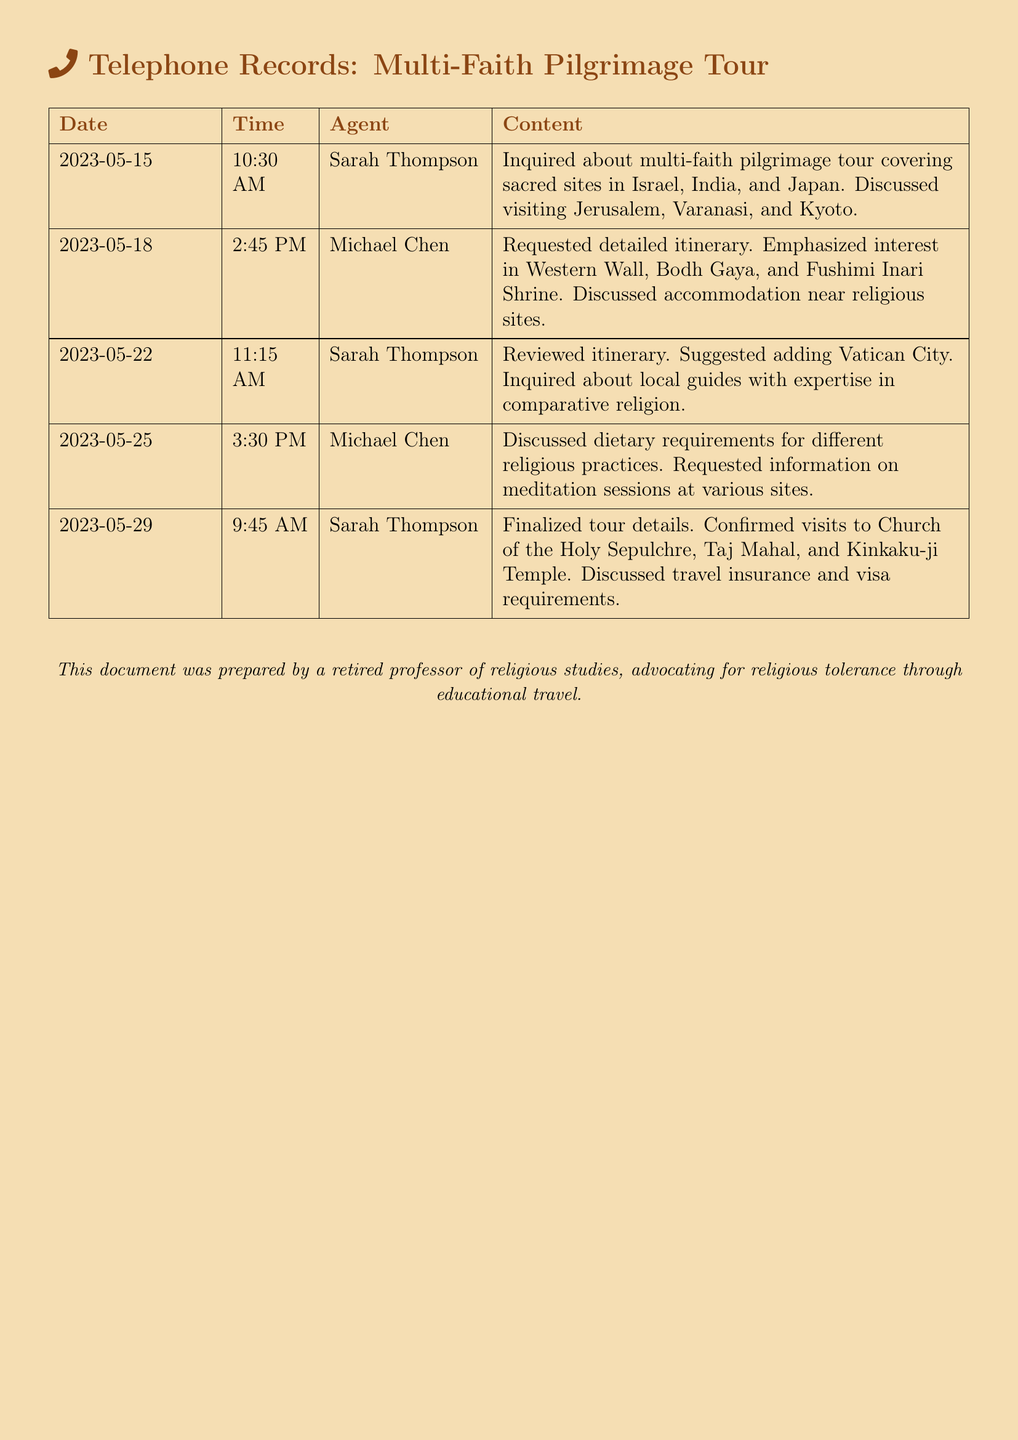What is the date of the first inquiry? The first inquiry was made on 2023-05-15 according to the telephone records.
Answer: 2023-05-15 Who inquired about adding Vatican City to the itinerary? The document shows that Sarah Thompson suggested adding Vatican City during a call on 2023-05-22.
Answer: Sarah Thompson What sacred site was discussed on 2023-05-18? The discussion on 2023-05-18 included the Western Wall as a major site of interest.
Answer: Western Wall How many calls did Sarah Thompson make regarding the tour? By counting the entries, Sarah Thompson made three calls on the recorded dates.
Answer: 3 What was one focus of the conversation on 2023-05-25? The conversation on 2023-05-25 focused on dietary requirements for different religious practices.
Answer: Dietary requirements What time did Michael Chen's first call occur? The first call from Michael Chen was at 2:45 PM on 2023-05-18.
Answer: 2:45 PM Which temple was confirmed to be visited on 2023-05-29? On 2023-05-29, Kinkaku-ji Temple was confirmed as one of the tour stops.
Answer: Kinkaku-ji Temple Which agent reviewed the itinerary on 2023-05-22? The itinerary was reviewed by Sarah Thompson on that day according to the records.
Answer: Sarah Thompson What is the main purpose of the calls recorded? The main purpose of the calls recorded is planning a multi-faith pilgrimage tour.
Answer: Planning a multi-faith pilgrimage tour 